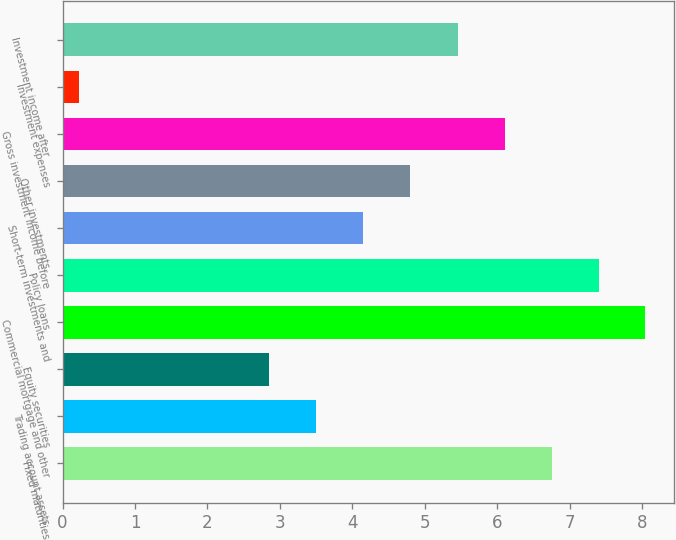Convert chart. <chart><loc_0><loc_0><loc_500><loc_500><bar_chart><fcel>Fixed maturities<fcel>Trading account assets<fcel>Equity securities<fcel>Commercial mortgage and other<fcel>Policy loans<fcel>Short-term investments and<fcel>Other investments<fcel>Gross investment income before<fcel>Investment expenses<fcel>Investment income after<nl><fcel>6.76<fcel>3.5<fcel>2.85<fcel>8.04<fcel>7.4<fcel>4.14<fcel>4.79<fcel>6.11<fcel>0.23<fcel>5.46<nl></chart> 